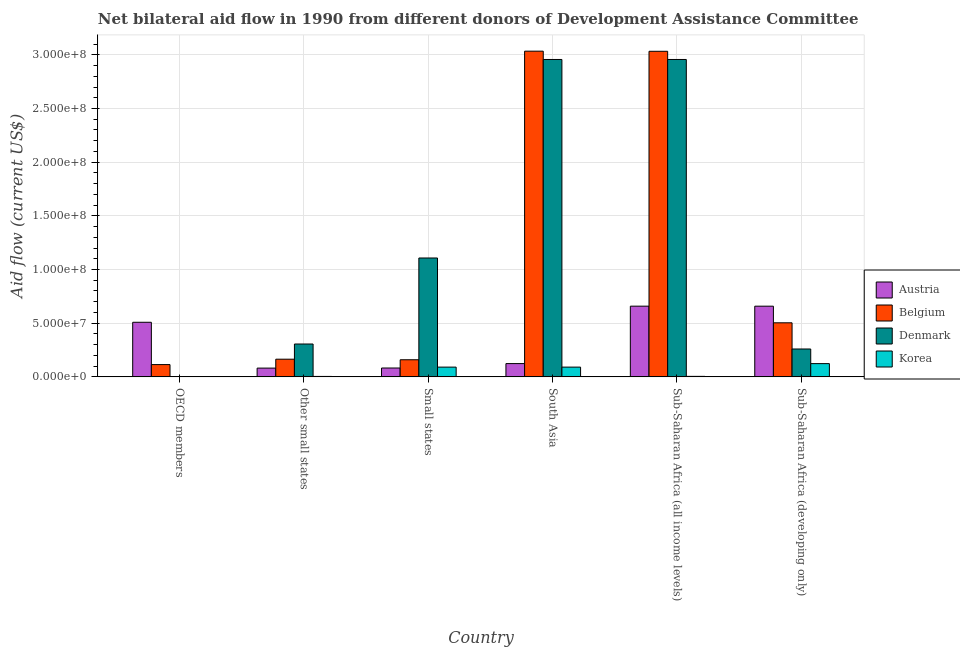How many different coloured bars are there?
Your answer should be very brief. 4. How many bars are there on the 3rd tick from the left?
Provide a short and direct response. 4. What is the label of the 2nd group of bars from the left?
Give a very brief answer. Other small states. In how many cases, is the number of bars for a given country not equal to the number of legend labels?
Give a very brief answer. 0. What is the amount of aid given by austria in Small states?
Keep it short and to the point. 8.25e+06. Across all countries, what is the maximum amount of aid given by austria?
Ensure brevity in your answer.  6.59e+07. Across all countries, what is the minimum amount of aid given by austria?
Give a very brief answer. 8.17e+06. In which country was the amount of aid given by belgium minimum?
Offer a terse response. OECD members. What is the total amount of aid given by austria in the graph?
Your answer should be very brief. 2.11e+08. What is the difference between the amount of aid given by belgium in Other small states and that in Sub-Saharan Africa (developing only)?
Offer a terse response. -3.39e+07. What is the difference between the amount of aid given by austria in Sub-Saharan Africa (developing only) and the amount of aid given by korea in South Asia?
Make the answer very short. 5.68e+07. What is the average amount of aid given by austria per country?
Offer a terse response. 3.52e+07. What is the difference between the amount of aid given by austria and amount of aid given by korea in Sub-Saharan Africa (developing only)?
Offer a terse response. 5.35e+07. In how many countries, is the amount of aid given by belgium greater than 40000000 US$?
Offer a very short reply. 3. What is the ratio of the amount of aid given by korea in Other small states to that in Sub-Saharan Africa (all income levels)?
Give a very brief answer. 0.87. Is the amount of aid given by belgium in Other small states less than that in Sub-Saharan Africa (developing only)?
Ensure brevity in your answer.  Yes. What is the difference between the highest and the second highest amount of aid given by korea?
Make the answer very short. 3.25e+06. What is the difference between the highest and the lowest amount of aid given by belgium?
Ensure brevity in your answer.  2.92e+08. In how many countries, is the amount of aid given by korea greater than the average amount of aid given by korea taken over all countries?
Offer a terse response. 3. What does the 4th bar from the left in Small states represents?
Provide a succinct answer. Korea. What does the 1st bar from the right in Sub-Saharan Africa (developing only) represents?
Offer a terse response. Korea. Is it the case that in every country, the sum of the amount of aid given by austria and amount of aid given by belgium is greater than the amount of aid given by denmark?
Offer a terse response. No. How many bars are there?
Give a very brief answer. 24. How many countries are there in the graph?
Your response must be concise. 6. Are the values on the major ticks of Y-axis written in scientific E-notation?
Your response must be concise. Yes. How are the legend labels stacked?
Your answer should be compact. Vertical. What is the title of the graph?
Offer a terse response. Net bilateral aid flow in 1990 from different donors of Development Assistance Committee. Does "Quality of logistic services" appear as one of the legend labels in the graph?
Keep it short and to the point. No. What is the label or title of the Y-axis?
Keep it short and to the point. Aid flow (current US$). What is the Aid flow (current US$) in Austria in OECD members?
Your answer should be very brief. 5.09e+07. What is the Aid flow (current US$) of Belgium in OECD members?
Offer a terse response. 1.14e+07. What is the Aid flow (current US$) in Denmark in OECD members?
Your response must be concise. 4.00e+04. What is the Aid flow (current US$) of Austria in Other small states?
Make the answer very short. 8.17e+06. What is the Aid flow (current US$) in Belgium in Other small states?
Your answer should be compact. 1.65e+07. What is the Aid flow (current US$) in Denmark in Other small states?
Keep it short and to the point. 3.06e+07. What is the Aid flow (current US$) in Austria in Small states?
Your response must be concise. 8.25e+06. What is the Aid flow (current US$) in Belgium in Small states?
Ensure brevity in your answer.  1.59e+07. What is the Aid flow (current US$) in Denmark in Small states?
Keep it short and to the point. 1.11e+08. What is the Aid flow (current US$) in Korea in Small states?
Offer a terse response. 9.09e+06. What is the Aid flow (current US$) in Austria in South Asia?
Your answer should be compact. 1.24e+07. What is the Aid flow (current US$) of Belgium in South Asia?
Keep it short and to the point. 3.03e+08. What is the Aid flow (current US$) in Denmark in South Asia?
Provide a succinct answer. 2.96e+08. What is the Aid flow (current US$) of Korea in South Asia?
Ensure brevity in your answer.  9.09e+06. What is the Aid flow (current US$) in Austria in Sub-Saharan Africa (all income levels)?
Your answer should be very brief. 6.59e+07. What is the Aid flow (current US$) in Belgium in Sub-Saharan Africa (all income levels)?
Give a very brief answer. 3.03e+08. What is the Aid flow (current US$) in Denmark in Sub-Saharan Africa (all income levels)?
Your answer should be compact. 2.96e+08. What is the Aid flow (current US$) in Korea in Sub-Saharan Africa (all income levels)?
Ensure brevity in your answer.  4.70e+05. What is the Aid flow (current US$) in Austria in Sub-Saharan Africa (developing only)?
Offer a very short reply. 6.59e+07. What is the Aid flow (current US$) in Belgium in Sub-Saharan Africa (developing only)?
Your answer should be compact. 5.04e+07. What is the Aid flow (current US$) in Denmark in Sub-Saharan Africa (developing only)?
Offer a very short reply. 2.60e+07. What is the Aid flow (current US$) of Korea in Sub-Saharan Africa (developing only)?
Keep it short and to the point. 1.23e+07. Across all countries, what is the maximum Aid flow (current US$) of Austria?
Offer a terse response. 6.59e+07. Across all countries, what is the maximum Aid flow (current US$) of Belgium?
Offer a terse response. 3.03e+08. Across all countries, what is the maximum Aid flow (current US$) of Denmark?
Keep it short and to the point. 2.96e+08. Across all countries, what is the maximum Aid flow (current US$) in Korea?
Provide a short and direct response. 1.23e+07. Across all countries, what is the minimum Aid flow (current US$) of Austria?
Offer a very short reply. 8.17e+06. Across all countries, what is the minimum Aid flow (current US$) in Belgium?
Your response must be concise. 1.14e+07. Across all countries, what is the minimum Aid flow (current US$) in Denmark?
Ensure brevity in your answer.  4.00e+04. Across all countries, what is the minimum Aid flow (current US$) of Korea?
Keep it short and to the point. 1.10e+05. What is the total Aid flow (current US$) of Austria in the graph?
Give a very brief answer. 2.11e+08. What is the total Aid flow (current US$) of Belgium in the graph?
Make the answer very short. 7.01e+08. What is the total Aid flow (current US$) of Denmark in the graph?
Provide a succinct answer. 7.59e+08. What is the total Aid flow (current US$) in Korea in the graph?
Your response must be concise. 3.15e+07. What is the difference between the Aid flow (current US$) of Austria in OECD members and that in Other small states?
Give a very brief answer. 4.27e+07. What is the difference between the Aid flow (current US$) in Belgium in OECD members and that in Other small states?
Keep it short and to the point. -5.01e+06. What is the difference between the Aid flow (current US$) of Denmark in OECD members and that in Other small states?
Provide a succinct answer. -3.06e+07. What is the difference between the Aid flow (current US$) of Austria in OECD members and that in Small states?
Make the answer very short. 4.26e+07. What is the difference between the Aid flow (current US$) in Belgium in OECD members and that in Small states?
Your answer should be very brief. -4.49e+06. What is the difference between the Aid flow (current US$) of Denmark in OECD members and that in Small states?
Ensure brevity in your answer.  -1.11e+08. What is the difference between the Aid flow (current US$) of Korea in OECD members and that in Small states?
Make the answer very short. -8.98e+06. What is the difference between the Aid flow (current US$) in Austria in OECD members and that in South Asia?
Keep it short and to the point. 3.85e+07. What is the difference between the Aid flow (current US$) in Belgium in OECD members and that in South Asia?
Your response must be concise. -2.92e+08. What is the difference between the Aid flow (current US$) in Denmark in OECD members and that in South Asia?
Your answer should be compact. -2.96e+08. What is the difference between the Aid flow (current US$) of Korea in OECD members and that in South Asia?
Provide a succinct answer. -8.98e+06. What is the difference between the Aid flow (current US$) in Austria in OECD members and that in Sub-Saharan Africa (all income levels)?
Offer a terse response. -1.50e+07. What is the difference between the Aid flow (current US$) of Belgium in OECD members and that in Sub-Saharan Africa (all income levels)?
Your answer should be compact. -2.92e+08. What is the difference between the Aid flow (current US$) in Denmark in OECD members and that in Sub-Saharan Africa (all income levels)?
Provide a short and direct response. -2.96e+08. What is the difference between the Aid flow (current US$) of Korea in OECD members and that in Sub-Saharan Africa (all income levels)?
Offer a terse response. -3.60e+05. What is the difference between the Aid flow (current US$) in Austria in OECD members and that in Sub-Saharan Africa (developing only)?
Keep it short and to the point. -1.50e+07. What is the difference between the Aid flow (current US$) in Belgium in OECD members and that in Sub-Saharan Africa (developing only)?
Keep it short and to the point. -3.89e+07. What is the difference between the Aid flow (current US$) in Denmark in OECD members and that in Sub-Saharan Africa (developing only)?
Provide a short and direct response. -2.59e+07. What is the difference between the Aid flow (current US$) of Korea in OECD members and that in Sub-Saharan Africa (developing only)?
Offer a very short reply. -1.22e+07. What is the difference between the Aid flow (current US$) in Belgium in Other small states and that in Small states?
Offer a terse response. 5.20e+05. What is the difference between the Aid flow (current US$) of Denmark in Other small states and that in Small states?
Offer a very short reply. -8.01e+07. What is the difference between the Aid flow (current US$) of Korea in Other small states and that in Small states?
Give a very brief answer. -8.68e+06. What is the difference between the Aid flow (current US$) in Austria in Other small states and that in South Asia?
Your answer should be compact. -4.21e+06. What is the difference between the Aid flow (current US$) of Belgium in Other small states and that in South Asia?
Your answer should be compact. -2.87e+08. What is the difference between the Aid flow (current US$) in Denmark in Other small states and that in South Asia?
Make the answer very short. -2.65e+08. What is the difference between the Aid flow (current US$) of Korea in Other small states and that in South Asia?
Give a very brief answer. -8.68e+06. What is the difference between the Aid flow (current US$) in Austria in Other small states and that in Sub-Saharan Africa (all income levels)?
Make the answer very short. -5.77e+07. What is the difference between the Aid flow (current US$) in Belgium in Other small states and that in Sub-Saharan Africa (all income levels)?
Offer a very short reply. -2.87e+08. What is the difference between the Aid flow (current US$) in Denmark in Other small states and that in Sub-Saharan Africa (all income levels)?
Provide a short and direct response. -2.65e+08. What is the difference between the Aid flow (current US$) in Korea in Other small states and that in Sub-Saharan Africa (all income levels)?
Ensure brevity in your answer.  -6.00e+04. What is the difference between the Aid flow (current US$) in Austria in Other small states and that in Sub-Saharan Africa (developing only)?
Offer a very short reply. -5.77e+07. What is the difference between the Aid flow (current US$) in Belgium in Other small states and that in Sub-Saharan Africa (developing only)?
Offer a very short reply. -3.39e+07. What is the difference between the Aid flow (current US$) of Denmark in Other small states and that in Sub-Saharan Africa (developing only)?
Provide a succinct answer. 4.64e+06. What is the difference between the Aid flow (current US$) in Korea in Other small states and that in Sub-Saharan Africa (developing only)?
Keep it short and to the point. -1.19e+07. What is the difference between the Aid flow (current US$) of Austria in Small states and that in South Asia?
Keep it short and to the point. -4.13e+06. What is the difference between the Aid flow (current US$) of Belgium in Small states and that in South Asia?
Your response must be concise. -2.87e+08. What is the difference between the Aid flow (current US$) in Denmark in Small states and that in South Asia?
Make the answer very short. -1.85e+08. What is the difference between the Aid flow (current US$) in Korea in Small states and that in South Asia?
Provide a succinct answer. 0. What is the difference between the Aid flow (current US$) in Austria in Small states and that in Sub-Saharan Africa (all income levels)?
Offer a terse response. -5.76e+07. What is the difference between the Aid flow (current US$) in Belgium in Small states and that in Sub-Saharan Africa (all income levels)?
Keep it short and to the point. -2.87e+08. What is the difference between the Aid flow (current US$) of Denmark in Small states and that in Sub-Saharan Africa (all income levels)?
Your response must be concise. -1.85e+08. What is the difference between the Aid flow (current US$) of Korea in Small states and that in Sub-Saharan Africa (all income levels)?
Offer a terse response. 8.62e+06. What is the difference between the Aid flow (current US$) of Austria in Small states and that in Sub-Saharan Africa (developing only)?
Offer a very short reply. -5.76e+07. What is the difference between the Aid flow (current US$) of Belgium in Small states and that in Sub-Saharan Africa (developing only)?
Offer a terse response. -3.44e+07. What is the difference between the Aid flow (current US$) in Denmark in Small states and that in Sub-Saharan Africa (developing only)?
Keep it short and to the point. 8.48e+07. What is the difference between the Aid flow (current US$) of Korea in Small states and that in Sub-Saharan Africa (developing only)?
Make the answer very short. -3.25e+06. What is the difference between the Aid flow (current US$) of Austria in South Asia and that in Sub-Saharan Africa (all income levels)?
Keep it short and to the point. -5.35e+07. What is the difference between the Aid flow (current US$) in Belgium in South Asia and that in Sub-Saharan Africa (all income levels)?
Ensure brevity in your answer.  1.20e+05. What is the difference between the Aid flow (current US$) of Denmark in South Asia and that in Sub-Saharan Africa (all income levels)?
Your answer should be very brief. 0. What is the difference between the Aid flow (current US$) of Korea in South Asia and that in Sub-Saharan Africa (all income levels)?
Your answer should be compact. 8.62e+06. What is the difference between the Aid flow (current US$) in Austria in South Asia and that in Sub-Saharan Africa (developing only)?
Your answer should be very brief. -5.35e+07. What is the difference between the Aid flow (current US$) in Belgium in South Asia and that in Sub-Saharan Africa (developing only)?
Your answer should be compact. 2.53e+08. What is the difference between the Aid flow (current US$) of Denmark in South Asia and that in Sub-Saharan Africa (developing only)?
Your answer should be very brief. 2.70e+08. What is the difference between the Aid flow (current US$) of Korea in South Asia and that in Sub-Saharan Africa (developing only)?
Give a very brief answer. -3.25e+06. What is the difference between the Aid flow (current US$) in Belgium in Sub-Saharan Africa (all income levels) and that in Sub-Saharan Africa (developing only)?
Offer a very short reply. 2.53e+08. What is the difference between the Aid flow (current US$) of Denmark in Sub-Saharan Africa (all income levels) and that in Sub-Saharan Africa (developing only)?
Your response must be concise. 2.70e+08. What is the difference between the Aid flow (current US$) in Korea in Sub-Saharan Africa (all income levels) and that in Sub-Saharan Africa (developing only)?
Provide a short and direct response. -1.19e+07. What is the difference between the Aid flow (current US$) of Austria in OECD members and the Aid flow (current US$) of Belgium in Other small states?
Keep it short and to the point. 3.44e+07. What is the difference between the Aid flow (current US$) of Austria in OECD members and the Aid flow (current US$) of Denmark in Other small states?
Offer a terse response. 2.02e+07. What is the difference between the Aid flow (current US$) of Austria in OECD members and the Aid flow (current US$) of Korea in Other small states?
Provide a succinct answer. 5.04e+07. What is the difference between the Aid flow (current US$) in Belgium in OECD members and the Aid flow (current US$) in Denmark in Other small states?
Your answer should be compact. -1.92e+07. What is the difference between the Aid flow (current US$) of Belgium in OECD members and the Aid flow (current US$) of Korea in Other small states?
Offer a very short reply. 1.10e+07. What is the difference between the Aid flow (current US$) of Denmark in OECD members and the Aid flow (current US$) of Korea in Other small states?
Make the answer very short. -3.70e+05. What is the difference between the Aid flow (current US$) in Austria in OECD members and the Aid flow (current US$) in Belgium in Small states?
Provide a succinct answer. 3.49e+07. What is the difference between the Aid flow (current US$) in Austria in OECD members and the Aid flow (current US$) in Denmark in Small states?
Offer a very short reply. -5.99e+07. What is the difference between the Aid flow (current US$) in Austria in OECD members and the Aid flow (current US$) in Korea in Small states?
Your answer should be very brief. 4.18e+07. What is the difference between the Aid flow (current US$) of Belgium in OECD members and the Aid flow (current US$) of Denmark in Small states?
Your answer should be very brief. -9.93e+07. What is the difference between the Aid flow (current US$) of Belgium in OECD members and the Aid flow (current US$) of Korea in Small states?
Keep it short and to the point. 2.36e+06. What is the difference between the Aid flow (current US$) of Denmark in OECD members and the Aid flow (current US$) of Korea in Small states?
Keep it short and to the point. -9.05e+06. What is the difference between the Aid flow (current US$) in Austria in OECD members and the Aid flow (current US$) in Belgium in South Asia?
Give a very brief answer. -2.53e+08. What is the difference between the Aid flow (current US$) in Austria in OECD members and the Aid flow (current US$) in Denmark in South Asia?
Your answer should be compact. -2.45e+08. What is the difference between the Aid flow (current US$) of Austria in OECD members and the Aid flow (current US$) of Korea in South Asia?
Keep it short and to the point. 4.18e+07. What is the difference between the Aid flow (current US$) of Belgium in OECD members and the Aid flow (current US$) of Denmark in South Asia?
Keep it short and to the point. -2.84e+08. What is the difference between the Aid flow (current US$) in Belgium in OECD members and the Aid flow (current US$) in Korea in South Asia?
Your answer should be very brief. 2.36e+06. What is the difference between the Aid flow (current US$) of Denmark in OECD members and the Aid flow (current US$) of Korea in South Asia?
Give a very brief answer. -9.05e+06. What is the difference between the Aid flow (current US$) of Austria in OECD members and the Aid flow (current US$) of Belgium in Sub-Saharan Africa (all income levels)?
Provide a succinct answer. -2.52e+08. What is the difference between the Aid flow (current US$) in Austria in OECD members and the Aid flow (current US$) in Denmark in Sub-Saharan Africa (all income levels)?
Your answer should be very brief. -2.45e+08. What is the difference between the Aid flow (current US$) of Austria in OECD members and the Aid flow (current US$) of Korea in Sub-Saharan Africa (all income levels)?
Your answer should be compact. 5.04e+07. What is the difference between the Aid flow (current US$) in Belgium in OECD members and the Aid flow (current US$) in Denmark in Sub-Saharan Africa (all income levels)?
Offer a very short reply. -2.84e+08. What is the difference between the Aid flow (current US$) in Belgium in OECD members and the Aid flow (current US$) in Korea in Sub-Saharan Africa (all income levels)?
Provide a succinct answer. 1.10e+07. What is the difference between the Aid flow (current US$) in Denmark in OECD members and the Aid flow (current US$) in Korea in Sub-Saharan Africa (all income levels)?
Offer a very short reply. -4.30e+05. What is the difference between the Aid flow (current US$) in Austria in OECD members and the Aid flow (current US$) in Denmark in Sub-Saharan Africa (developing only)?
Give a very brief answer. 2.49e+07. What is the difference between the Aid flow (current US$) of Austria in OECD members and the Aid flow (current US$) of Korea in Sub-Saharan Africa (developing only)?
Make the answer very short. 3.85e+07. What is the difference between the Aid flow (current US$) of Belgium in OECD members and the Aid flow (current US$) of Denmark in Sub-Saharan Africa (developing only)?
Provide a short and direct response. -1.45e+07. What is the difference between the Aid flow (current US$) in Belgium in OECD members and the Aid flow (current US$) in Korea in Sub-Saharan Africa (developing only)?
Your response must be concise. -8.90e+05. What is the difference between the Aid flow (current US$) in Denmark in OECD members and the Aid flow (current US$) in Korea in Sub-Saharan Africa (developing only)?
Give a very brief answer. -1.23e+07. What is the difference between the Aid flow (current US$) in Austria in Other small states and the Aid flow (current US$) in Belgium in Small states?
Make the answer very short. -7.77e+06. What is the difference between the Aid flow (current US$) of Austria in Other small states and the Aid flow (current US$) of Denmark in Small states?
Make the answer very short. -1.03e+08. What is the difference between the Aid flow (current US$) in Austria in Other small states and the Aid flow (current US$) in Korea in Small states?
Ensure brevity in your answer.  -9.20e+05. What is the difference between the Aid flow (current US$) of Belgium in Other small states and the Aid flow (current US$) of Denmark in Small states?
Make the answer very short. -9.43e+07. What is the difference between the Aid flow (current US$) in Belgium in Other small states and the Aid flow (current US$) in Korea in Small states?
Provide a succinct answer. 7.37e+06. What is the difference between the Aid flow (current US$) of Denmark in Other small states and the Aid flow (current US$) of Korea in Small states?
Make the answer very short. 2.15e+07. What is the difference between the Aid flow (current US$) in Austria in Other small states and the Aid flow (current US$) in Belgium in South Asia?
Provide a short and direct response. -2.95e+08. What is the difference between the Aid flow (current US$) of Austria in Other small states and the Aid flow (current US$) of Denmark in South Asia?
Offer a terse response. -2.88e+08. What is the difference between the Aid flow (current US$) of Austria in Other small states and the Aid flow (current US$) of Korea in South Asia?
Provide a short and direct response. -9.20e+05. What is the difference between the Aid flow (current US$) in Belgium in Other small states and the Aid flow (current US$) in Denmark in South Asia?
Your response must be concise. -2.79e+08. What is the difference between the Aid flow (current US$) in Belgium in Other small states and the Aid flow (current US$) in Korea in South Asia?
Offer a very short reply. 7.37e+06. What is the difference between the Aid flow (current US$) in Denmark in Other small states and the Aid flow (current US$) in Korea in South Asia?
Your answer should be very brief. 2.15e+07. What is the difference between the Aid flow (current US$) of Austria in Other small states and the Aid flow (current US$) of Belgium in Sub-Saharan Africa (all income levels)?
Your response must be concise. -2.95e+08. What is the difference between the Aid flow (current US$) in Austria in Other small states and the Aid flow (current US$) in Denmark in Sub-Saharan Africa (all income levels)?
Make the answer very short. -2.88e+08. What is the difference between the Aid flow (current US$) in Austria in Other small states and the Aid flow (current US$) in Korea in Sub-Saharan Africa (all income levels)?
Provide a short and direct response. 7.70e+06. What is the difference between the Aid flow (current US$) in Belgium in Other small states and the Aid flow (current US$) in Denmark in Sub-Saharan Africa (all income levels)?
Offer a very short reply. -2.79e+08. What is the difference between the Aid flow (current US$) of Belgium in Other small states and the Aid flow (current US$) of Korea in Sub-Saharan Africa (all income levels)?
Offer a very short reply. 1.60e+07. What is the difference between the Aid flow (current US$) in Denmark in Other small states and the Aid flow (current US$) in Korea in Sub-Saharan Africa (all income levels)?
Keep it short and to the point. 3.01e+07. What is the difference between the Aid flow (current US$) of Austria in Other small states and the Aid flow (current US$) of Belgium in Sub-Saharan Africa (developing only)?
Your answer should be very brief. -4.22e+07. What is the difference between the Aid flow (current US$) in Austria in Other small states and the Aid flow (current US$) in Denmark in Sub-Saharan Africa (developing only)?
Keep it short and to the point. -1.78e+07. What is the difference between the Aid flow (current US$) in Austria in Other small states and the Aid flow (current US$) in Korea in Sub-Saharan Africa (developing only)?
Make the answer very short. -4.17e+06. What is the difference between the Aid flow (current US$) in Belgium in Other small states and the Aid flow (current US$) in Denmark in Sub-Saharan Africa (developing only)?
Ensure brevity in your answer.  -9.51e+06. What is the difference between the Aid flow (current US$) in Belgium in Other small states and the Aid flow (current US$) in Korea in Sub-Saharan Africa (developing only)?
Your response must be concise. 4.12e+06. What is the difference between the Aid flow (current US$) of Denmark in Other small states and the Aid flow (current US$) of Korea in Sub-Saharan Africa (developing only)?
Provide a succinct answer. 1.83e+07. What is the difference between the Aid flow (current US$) of Austria in Small states and the Aid flow (current US$) of Belgium in South Asia?
Offer a terse response. -2.95e+08. What is the difference between the Aid flow (current US$) of Austria in Small states and the Aid flow (current US$) of Denmark in South Asia?
Provide a short and direct response. -2.87e+08. What is the difference between the Aid flow (current US$) in Austria in Small states and the Aid flow (current US$) in Korea in South Asia?
Keep it short and to the point. -8.40e+05. What is the difference between the Aid flow (current US$) of Belgium in Small states and the Aid flow (current US$) of Denmark in South Asia?
Make the answer very short. -2.80e+08. What is the difference between the Aid flow (current US$) of Belgium in Small states and the Aid flow (current US$) of Korea in South Asia?
Ensure brevity in your answer.  6.85e+06. What is the difference between the Aid flow (current US$) in Denmark in Small states and the Aid flow (current US$) in Korea in South Asia?
Ensure brevity in your answer.  1.02e+08. What is the difference between the Aid flow (current US$) of Austria in Small states and the Aid flow (current US$) of Belgium in Sub-Saharan Africa (all income levels)?
Your answer should be very brief. -2.95e+08. What is the difference between the Aid flow (current US$) of Austria in Small states and the Aid flow (current US$) of Denmark in Sub-Saharan Africa (all income levels)?
Provide a short and direct response. -2.87e+08. What is the difference between the Aid flow (current US$) of Austria in Small states and the Aid flow (current US$) of Korea in Sub-Saharan Africa (all income levels)?
Make the answer very short. 7.78e+06. What is the difference between the Aid flow (current US$) of Belgium in Small states and the Aid flow (current US$) of Denmark in Sub-Saharan Africa (all income levels)?
Provide a succinct answer. -2.80e+08. What is the difference between the Aid flow (current US$) of Belgium in Small states and the Aid flow (current US$) of Korea in Sub-Saharan Africa (all income levels)?
Ensure brevity in your answer.  1.55e+07. What is the difference between the Aid flow (current US$) in Denmark in Small states and the Aid flow (current US$) in Korea in Sub-Saharan Africa (all income levels)?
Your answer should be very brief. 1.10e+08. What is the difference between the Aid flow (current US$) of Austria in Small states and the Aid flow (current US$) of Belgium in Sub-Saharan Africa (developing only)?
Your response must be concise. -4.21e+07. What is the difference between the Aid flow (current US$) in Austria in Small states and the Aid flow (current US$) in Denmark in Sub-Saharan Africa (developing only)?
Ensure brevity in your answer.  -1.77e+07. What is the difference between the Aid flow (current US$) of Austria in Small states and the Aid flow (current US$) of Korea in Sub-Saharan Africa (developing only)?
Provide a short and direct response. -4.09e+06. What is the difference between the Aid flow (current US$) of Belgium in Small states and the Aid flow (current US$) of Denmark in Sub-Saharan Africa (developing only)?
Provide a short and direct response. -1.00e+07. What is the difference between the Aid flow (current US$) in Belgium in Small states and the Aid flow (current US$) in Korea in Sub-Saharan Africa (developing only)?
Give a very brief answer. 3.60e+06. What is the difference between the Aid flow (current US$) in Denmark in Small states and the Aid flow (current US$) in Korea in Sub-Saharan Africa (developing only)?
Provide a succinct answer. 9.84e+07. What is the difference between the Aid flow (current US$) in Austria in South Asia and the Aid flow (current US$) in Belgium in Sub-Saharan Africa (all income levels)?
Your answer should be compact. -2.91e+08. What is the difference between the Aid flow (current US$) of Austria in South Asia and the Aid flow (current US$) of Denmark in Sub-Saharan Africa (all income levels)?
Your answer should be compact. -2.83e+08. What is the difference between the Aid flow (current US$) in Austria in South Asia and the Aid flow (current US$) in Korea in Sub-Saharan Africa (all income levels)?
Make the answer very short. 1.19e+07. What is the difference between the Aid flow (current US$) of Belgium in South Asia and the Aid flow (current US$) of Denmark in Sub-Saharan Africa (all income levels)?
Give a very brief answer. 7.74e+06. What is the difference between the Aid flow (current US$) of Belgium in South Asia and the Aid flow (current US$) of Korea in Sub-Saharan Africa (all income levels)?
Make the answer very short. 3.03e+08. What is the difference between the Aid flow (current US$) in Denmark in South Asia and the Aid flow (current US$) in Korea in Sub-Saharan Africa (all income levels)?
Ensure brevity in your answer.  2.95e+08. What is the difference between the Aid flow (current US$) in Austria in South Asia and the Aid flow (current US$) in Belgium in Sub-Saharan Africa (developing only)?
Make the answer very short. -3.80e+07. What is the difference between the Aid flow (current US$) of Austria in South Asia and the Aid flow (current US$) of Denmark in Sub-Saharan Africa (developing only)?
Ensure brevity in your answer.  -1.36e+07. What is the difference between the Aid flow (current US$) in Belgium in South Asia and the Aid flow (current US$) in Denmark in Sub-Saharan Africa (developing only)?
Keep it short and to the point. 2.77e+08. What is the difference between the Aid flow (current US$) of Belgium in South Asia and the Aid flow (current US$) of Korea in Sub-Saharan Africa (developing only)?
Give a very brief answer. 2.91e+08. What is the difference between the Aid flow (current US$) of Denmark in South Asia and the Aid flow (current US$) of Korea in Sub-Saharan Africa (developing only)?
Your answer should be very brief. 2.83e+08. What is the difference between the Aid flow (current US$) of Austria in Sub-Saharan Africa (all income levels) and the Aid flow (current US$) of Belgium in Sub-Saharan Africa (developing only)?
Make the answer very short. 1.55e+07. What is the difference between the Aid flow (current US$) in Austria in Sub-Saharan Africa (all income levels) and the Aid flow (current US$) in Denmark in Sub-Saharan Africa (developing only)?
Provide a succinct answer. 3.99e+07. What is the difference between the Aid flow (current US$) of Austria in Sub-Saharan Africa (all income levels) and the Aid flow (current US$) of Korea in Sub-Saharan Africa (developing only)?
Your answer should be compact. 5.35e+07. What is the difference between the Aid flow (current US$) of Belgium in Sub-Saharan Africa (all income levels) and the Aid flow (current US$) of Denmark in Sub-Saharan Africa (developing only)?
Offer a terse response. 2.77e+08. What is the difference between the Aid flow (current US$) of Belgium in Sub-Saharan Africa (all income levels) and the Aid flow (current US$) of Korea in Sub-Saharan Africa (developing only)?
Your answer should be compact. 2.91e+08. What is the difference between the Aid flow (current US$) in Denmark in Sub-Saharan Africa (all income levels) and the Aid flow (current US$) in Korea in Sub-Saharan Africa (developing only)?
Ensure brevity in your answer.  2.83e+08. What is the average Aid flow (current US$) in Austria per country?
Your answer should be compact. 3.52e+07. What is the average Aid flow (current US$) of Belgium per country?
Provide a short and direct response. 1.17e+08. What is the average Aid flow (current US$) in Denmark per country?
Provide a short and direct response. 1.26e+08. What is the average Aid flow (current US$) in Korea per country?
Offer a terse response. 5.25e+06. What is the difference between the Aid flow (current US$) in Austria and Aid flow (current US$) in Belgium in OECD members?
Offer a terse response. 3.94e+07. What is the difference between the Aid flow (current US$) in Austria and Aid flow (current US$) in Denmark in OECD members?
Offer a terse response. 5.08e+07. What is the difference between the Aid flow (current US$) of Austria and Aid flow (current US$) of Korea in OECD members?
Your answer should be very brief. 5.08e+07. What is the difference between the Aid flow (current US$) of Belgium and Aid flow (current US$) of Denmark in OECD members?
Your answer should be very brief. 1.14e+07. What is the difference between the Aid flow (current US$) of Belgium and Aid flow (current US$) of Korea in OECD members?
Provide a short and direct response. 1.13e+07. What is the difference between the Aid flow (current US$) in Austria and Aid flow (current US$) in Belgium in Other small states?
Offer a terse response. -8.29e+06. What is the difference between the Aid flow (current US$) of Austria and Aid flow (current US$) of Denmark in Other small states?
Make the answer very short. -2.24e+07. What is the difference between the Aid flow (current US$) of Austria and Aid flow (current US$) of Korea in Other small states?
Offer a terse response. 7.76e+06. What is the difference between the Aid flow (current US$) of Belgium and Aid flow (current US$) of Denmark in Other small states?
Your response must be concise. -1.42e+07. What is the difference between the Aid flow (current US$) of Belgium and Aid flow (current US$) of Korea in Other small states?
Ensure brevity in your answer.  1.60e+07. What is the difference between the Aid flow (current US$) in Denmark and Aid flow (current US$) in Korea in Other small states?
Offer a terse response. 3.02e+07. What is the difference between the Aid flow (current US$) of Austria and Aid flow (current US$) of Belgium in Small states?
Offer a very short reply. -7.69e+06. What is the difference between the Aid flow (current US$) in Austria and Aid flow (current US$) in Denmark in Small states?
Your answer should be very brief. -1.02e+08. What is the difference between the Aid flow (current US$) in Austria and Aid flow (current US$) in Korea in Small states?
Offer a terse response. -8.40e+05. What is the difference between the Aid flow (current US$) in Belgium and Aid flow (current US$) in Denmark in Small states?
Give a very brief answer. -9.48e+07. What is the difference between the Aid flow (current US$) in Belgium and Aid flow (current US$) in Korea in Small states?
Your answer should be very brief. 6.85e+06. What is the difference between the Aid flow (current US$) in Denmark and Aid flow (current US$) in Korea in Small states?
Offer a very short reply. 1.02e+08. What is the difference between the Aid flow (current US$) in Austria and Aid flow (current US$) in Belgium in South Asia?
Offer a very short reply. -2.91e+08. What is the difference between the Aid flow (current US$) in Austria and Aid flow (current US$) in Denmark in South Asia?
Offer a very short reply. -2.83e+08. What is the difference between the Aid flow (current US$) in Austria and Aid flow (current US$) in Korea in South Asia?
Provide a succinct answer. 3.29e+06. What is the difference between the Aid flow (current US$) of Belgium and Aid flow (current US$) of Denmark in South Asia?
Your response must be concise. 7.74e+06. What is the difference between the Aid flow (current US$) of Belgium and Aid flow (current US$) of Korea in South Asia?
Your answer should be compact. 2.94e+08. What is the difference between the Aid flow (current US$) of Denmark and Aid flow (current US$) of Korea in South Asia?
Your answer should be compact. 2.87e+08. What is the difference between the Aid flow (current US$) in Austria and Aid flow (current US$) in Belgium in Sub-Saharan Africa (all income levels)?
Offer a terse response. -2.37e+08. What is the difference between the Aid flow (current US$) in Austria and Aid flow (current US$) in Denmark in Sub-Saharan Africa (all income levels)?
Offer a terse response. -2.30e+08. What is the difference between the Aid flow (current US$) of Austria and Aid flow (current US$) of Korea in Sub-Saharan Africa (all income levels)?
Give a very brief answer. 6.54e+07. What is the difference between the Aid flow (current US$) in Belgium and Aid flow (current US$) in Denmark in Sub-Saharan Africa (all income levels)?
Offer a terse response. 7.62e+06. What is the difference between the Aid flow (current US$) of Belgium and Aid flow (current US$) of Korea in Sub-Saharan Africa (all income levels)?
Keep it short and to the point. 3.03e+08. What is the difference between the Aid flow (current US$) in Denmark and Aid flow (current US$) in Korea in Sub-Saharan Africa (all income levels)?
Provide a short and direct response. 2.95e+08. What is the difference between the Aid flow (current US$) in Austria and Aid flow (current US$) in Belgium in Sub-Saharan Africa (developing only)?
Ensure brevity in your answer.  1.55e+07. What is the difference between the Aid flow (current US$) of Austria and Aid flow (current US$) of Denmark in Sub-Saharan Africa (developing only)?
Offer a very short reply. 3.99e+07. What is the difference between the Aid flow (current US$) of Austria and Aid flow (current US$) of Korea in Sub-Saharan Africa (developing only)?
Keep it short and to the point. 5.35e+07. What is the difference between the Aid flow (current US$) of Belgium and Aid flow (current US$) of Denmark in Sub-Saharan Africa (developing only)?
Offer a very short reply. 2.44e+07. What is the difference between the Aid flow (current US$) of Belgium and Aid flow (current US$) of Korea in Sub-Saharan Africa (developing only)?
Your response must be concise. 3.80e+07. What is the difference between the Aid flow (current US$) of Denmark and Aid flow (current US$) of Korea in Sub-Saharan Africa (developing only)?
Give a very brief answer. 1.36e+07. What is the ratio of the Aid flow (current US$) of Austria in OECD members to that in Other small states?
Keep it short and to the point. 6.23. What is the ratio of the Aid flow (current US$) in Belgium in OECD members to that in Other small states?
Make the answer very short. 0.7. What is the ratio of the Aid flow (current US$) in Denmark in OECD members to that in Other small states?
Provide a short and direct response. 0. What is the ratio of the Aid flow (current US$) of Korea in OECD members to that in Other small states?
Your answer should be very brief. 0.27. What is the ratio of the Aid flow (current US$) of Austria in OECD members to that in Small states?
Give a very brief answer. 6.16. What is the ratio of the Aid flow (current US$) of Belgium in OECD members to that in Small states?
Provide a succinct answer. 0.72. What is the ratio of the Aid flow (current US$) in Korea in OECD members to that in Small states?
Provide a succinct answer. 0.01. What is the ratio of the Aid flow (current US$) of Austria in OECD members to that in South Asia?
Your answer should be very brief. 4.11. What is the ratio of the Aid flow (current US$) in Belgium in OECD members to that in South Asia?
Your response must be concise. 0.04. What is the ratio of the Aid flow (current US$) in Denmark in OECD members to that in South Asia?
Keep it short and to the point. 0. What is the ratio of the Aid flow (current US$) of Korea in OECD members to that in South Asia?
Offer a very short reply. 0.01. What is the ratio of the Aid flow (current US$) in Austria in OECD members to that in Sub-Saharan Africa (all income levels)?
Offer a terse response. 0.77. What is the ratio of the Aid flow (current US$) in Belgium in OECD members to that in Sub-Saharan Africa (all income levels)?
Keep it short and to the point. 0.04. What is the ratio of the Aid flow (current US$) in Korea in OECD members to that in Sub-Saharan Africa (all income levels)?
Offer a very short reply. 0.23. What is the ratio of the Aid flow (current US$) in Austria in OECD members to that in Sub-Saharan Africa (developing only)?
Your response must be concise. 0.77. What is the ratio of the Aid flow (current US$) of Belgium in OECD members to that in Sub-Saharan Africa (developing only)?
Provide a short and direct response. 0.23. What is the ratio of the Aid flow (current US$) in Denmark in OECD members to that in Sub-Saharan Africa (developing only)?
Offer a very short reply. 0. What is the ratio of the Aid flow (current US$) of Korea in OECD members to that in Sub-Saharan Africa (developing only)?
Your answer should be very brief. 0.01. What is the ratio of the Aid flow (current US$) in Austria in Other small states to that in Small states?
Your response must be concise. 0.99. What is the ratio of the Aid flow (current US$) in Belgium in Other small states to that in Small states?
Provide a short and direct response. 1.03. What is the ratio of the Aid flow (current US$) in Denmark in Other small states to that in Small states?
Keep it short and to the point. 0.28. What is the ratio of the Aid flow (current US$) in Korea in Other small states to that in Small states?
Your answer should be compact. 0.05. What is the ratio of the Aid flow (current US$) of Austria in Other small states to that in South Asia?
Make the answer very short. 0.66. What is the ratio of the Aid flow (current US$) of Belgium in Other small states to that in South Asia?
Offer a very short reply. 0.05. What is the ratio of the Aid flow (current US$) in Denmark in Other small states to that in South Asia?
Your answer should be very brief. 0.1. What is the ratio of the Aid flow (current US$) in Korea in Other small states to that in South Asia?
Keep it short and to the point. 0.05. What is the ratio of the Aid flow (current US$) of Austria in Other small states to that in Sub-Saharan Africa (all income levels)?
Provide a short and direct response. 0.12. What is the ratio of the Aid flow (current US$) of Belgium in Other small states to that in Sub-Saharan Africa (all income levels)?
Offer a very short reply. 0.05. What is the ratio of the Aid flow (current US$) of Denmark in Other small states to that in Sub-Saharan Africa (all income levels)?
Offer a very short reply. 0.1. What is the ratio of the Aid flow (current US$) in Korea in Other small states to that in Sub-Saharan Africa (all income levels)?
Your response must be concise. 0.87. What is the ratio of the Aid flow (current US$) in Austria in Other small states to that in Sub-Saharan Africa (developing only)?
Provide a short and direct response. 0.12. What is the ratio of the Aid flow (current US$) of Belgium in Other small states to that in Sub-Saharan Africa (developing only)?
Offer a terse response. 0.33. What is the ratio of the Aid flow (current US$) in Denmark in Other small states to that in Sub-Saharan Africa (developing only)?
Ensure brevity in your answer.  1.18. What is the ratio of the Aid flow (current US$) in Korea in Other small states to that in Sub-Saharan Africa (developing only)?
Make the answer very short. 0.03. What is the ratio of the Aid flow (current US$) in Austria in Small states to that in South Asia?
Your answer should be compact. 0.67. What is the ratio of the Aid flow (current US$) of Belgium in Small states to that in South Asia?
Your answer should be very brief. 0.05. What is the ratio of the Aid flow (current US$) of Denmark in Small states to that in South Asia?
Offer a terse response. 0.37. What is the ratio of the Aid flow (current US$) in Austria in Small states to that in Sub-Saharan Africa (all income levels)?
Provide a short and direct response. 0.13. What is the ratio of the Aid flow (current US$) of Belgium in Small states to that in Sub-Saharan Africa (all income levels)?
Keep it short and to the point. 0.05. What is the ratio of the Aid flow (current US$) in Denmark in Small states to that in Sub-Saharan Africa (all income levels)?
Offer a terse response. 0.37. What is the ratio of the Aid flow (current US$) in Korea in Small states to that in Sub-Saharan Africa (all income levels)?
Your answer should be compact. 19.34. What is the ratio of the Aid flow (current US$) in Austria in Small states to that in Sub-Saharan Africa (developing only)?
Your answer should be compact. 0.13. What is the ratio of the Aid flow (current US$) in Belgium in Small states to that in Sub-Saharan Africa (developing only)?
Give a very brief answer. 0.32. What is the ratio of the Aid flow (current US$) of Denmark in Small states to that in Sub-Saharan Africa (developing only)?
Offer a very short reply. 4.26. What is the ratio of the Aid flow (current US$) of Korea in Small states to that in Sub-Saharan Africa (developing only)?
Keep it short and to the point. 0.74. What is the ratio of the Aid flow (current US$) in Austria in South Asia to that in Sub-Saharan Africa (all income levels)?
Your answer should be very brief. 0.19. What is the ratio of the Aid flow (current US$) in Korea in South Asia to that in Sub-Saharan Africa (all income levels)?
Keep it short and to the point. 19.34. What is the ratio of the Aid flow (current US$) in Austria in South Asia to that in Sub-Saharan Africa (developing only)?
Offer a terse response. 0.19. What is the ratio of the Aid flow (current US$) of Belgium in South Asia to that in Sub-Saharan Africa (developing only)?
Provide a short and direct response. 6.02. What is the ratio of the Aid flow (current US$) in Denmark in South Asia to that in Sub-Saharan Africa (developing only)?
Provide a short and direct response. 11.39. What is the ratio of the Aid flow (current US$) in Korea in South Asia to that in Sub-Saharan Africa (developing only)?
Ensure brevity in your answer.  0.74. What is the ratio of the Aid flow (current US$) of Austria in Sub-Saharan Africa (all income levels) to that in Sub-Saharan Africa (developing only)?
Offer a terse response. 1. What is the ratio of the Aid flow (current US$) in Belgium in Sub-Saharan Africa (all income levels) to that in Sub-Saharan Africa (developing only)?
Make the answer very short. 6.02. What is the ratio of the Aid flow (current US$) in Denmark in Sub-Saharan Africa (all income levels) to that in Sub-Saharan Africa (developing only)?
Keep it short and to the point. 11.39. What is the ratio of the Aid flow (current US$) of Korea in Sub-Saharan Africa (all income levels) to that in Sub-Saharan Africa (developing only)?
Ensure brevity in your answer.  0.04. What is the difference between the highest and the second highest Aid flow (current US$) in Austria?
Ensure brevity in your answer.  10000. What is the difference between the highest and the second highest Aid flow (current US$) in Korea?
Your answer should be very brief. 3.25e+06. What is the difference between the highest and the lowest Aid flow (current US$) of Austria?
Your answer should be compact. 5.77e+07. What is the difference between the highest and the lowest Aid flow (current US$) in Belgium?
Give a very brief answer. 2.92e+08. What is the difference between the highest and the lowest Aid flow (current US$) of Denmark?
Make the answer very short. 2.96e+08. What is the difference between the highest and the lowest Aid flow (current US$) in Korea?
Offer a terse response. 1.22e+07. 